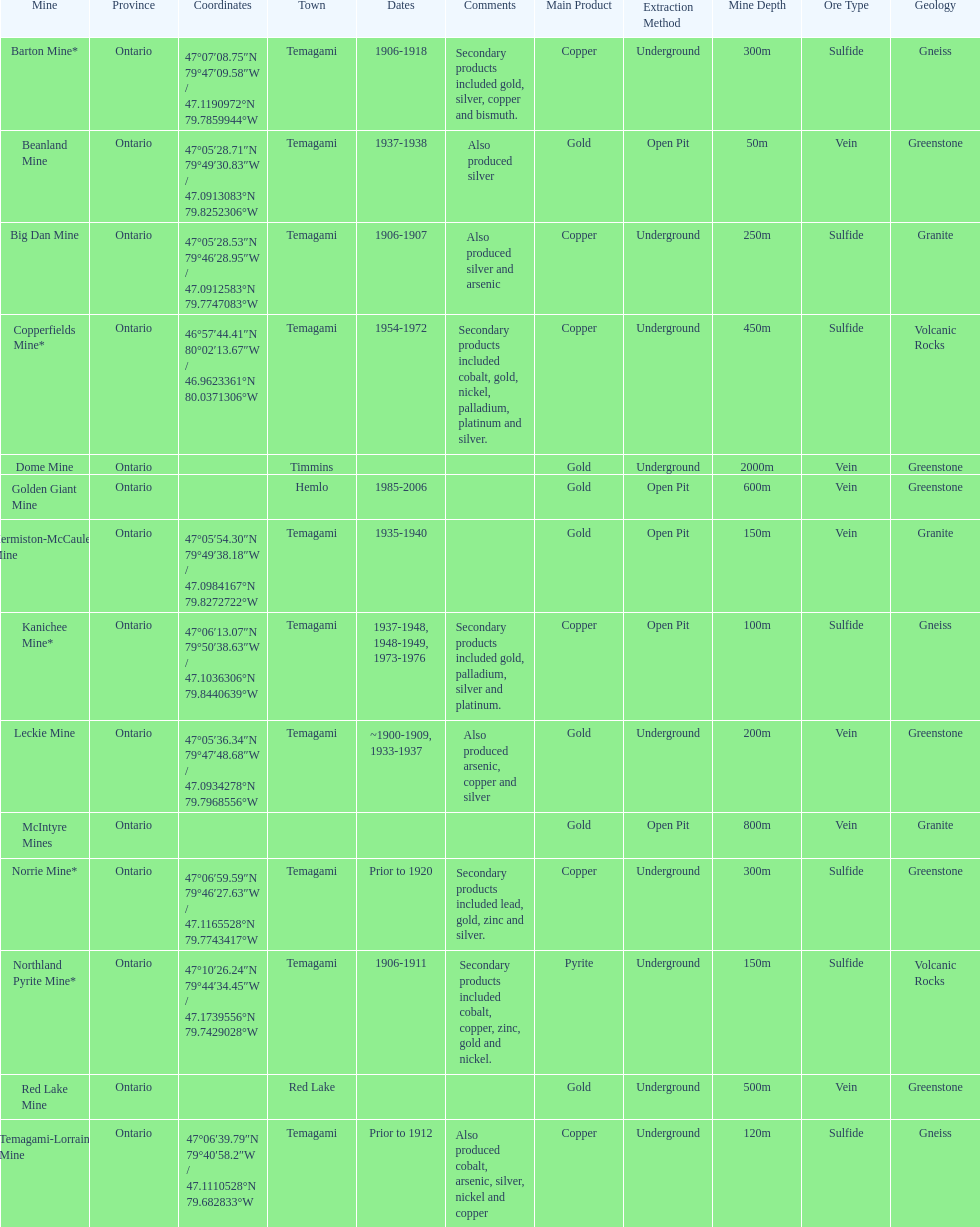Tell me the number of mines that also produced arsenic. 3. Help me parse the entirety of this table. {'header': ['Mine', 'Province', 'Coordinates', 'Town', 'Dates', 'Comments', 'Main Product', 'Extraction Method', 'Mine Depth', 'Ore Type', 'Geology'], 'rows': [['Barton Mine*', 'Ontario', '47°07′08.75″N 79°47′09.58″W\ufeff / \ufeff47.1190972°N 79.7859944°W', 'Temagami', '1906-1918', 'Secondary products included gold, silver, copper and bismuth.', 'Copper', 'Underground', '300m', 'Sulfide', 'Gneiss'], ['Beanland Mine', 'Ontario', '47°05′28.71″N 79°49′30.83″W\ufeff / \ufeff47.0913083°N 79.8252306°W', 'Temagami', '1937-1938', 'Also produced silver', 'Gold', 'Open Pit', '50m', 'Vein', 'Greenstone'], ['Big Dan Mine', 'Ontario', '47°05′28.53″N 79°46′28.95″W\ufeff / \ufeff47.0912583°N 79.7747083°W', 'Temagami', '1906-1907', 'Also produced silver and arsenic', 'Copper', 'Underground', '250m', 'Sulfide', 'Granite'], ['Copperfields Mine*', 'Ontario', '46°57′44.41″N 80°02′13.67″W\ufeff / \ufeff46.9623361°N 80.0371306°W', 'Temagami', '1954-1972', 'Secondary products included cobalt, gold, nickel, palladium, platinum and silver.', 'Copper', 'Underground', '450m', 'Sulfide', 'Volcanic Rocks'], ['Dome Mine', 'Ontario', '', 'Timmins', '', '', 'Gold', 'Underground', '2000m', 'Vein', 'Greenstone'], ['Golden Giant Mine', 'Ontario', '', 'Hemlo', '1985-2006', '', 'Gold', 'Open Pit', '600m', 'Vein', 'Greenstone'], ['Hermiston-McCauley Mine', 'Ontario', '47°05′54.30″N 79°49′38.18″W\ufeff / \ufeff47.0984167°N 79.8272722°W', 'Temagami', '1935-1940', '', 'Gold', 'Open Pit', '150m', 'Vein', 'Granite'], ['Kanichee Mine*', 'Ontario', '47°06′13.07″N 79°50′38.63″W\ufeff / \ufeff47.1036306°N 79.8440639°W', 'Temagami', '1937-1948, 1948-1949, 1973-1976', 'Secondary products included gold, palladium, silver and platinum.', 'Copper', 'Open Pit', '100m', 'Sulfide', 'Gneiss'], ['Leckie Mine', 'Ontario', '47°05′36.34″N 79°47′48.68″W\ufeff / \ufeff47.0934278°N 79.7968556°W', 'Temagami', '~1900-1909, 1933-1937', 'Also produced arsenic, copper and silver', 'Gold', 'Underground', '200m', 'Vein', 'Greenstone'], ['McIntyre Mines', 'Ontario', '', '', '', '', 'Gold', 'Open Pit', '800m', 'Vein', 'Granite'], ['Norrie Mine*', 'Ontario', '47°06′59.59″N 79°46′27.63″W\ufeff / \ufeff47.1165528°N 79.7743417°W', 'Temagami', 'Prior to 1920', 'Secondary products included lead, gold, zinc and silver.', 'Copper', 'Underground', '300m', 'Sulfide', 'Greenstone'], ['Northland Pyrite Mine*', 'Ontario', '47°10′26.24″N 79°44′34.45″W\ufeff / \ufeff47.1739556°N 79.7429028°W', 'Temagami', '1906-1911', 'Secondary products included cobalt, copper, zinc, gold and nickel.', 'Pyrite', 'Underground', '150m', 'Sulfide', 'Volcanic Rocks'], ['Red Lake Mine', 'Ontario', '', 'Red Lake', '', '', 'Gold', 'Underground', '500m', 'Vein', 'Greenstone'], ['Temagami-Lorrain Mine', 'Ontario', '47°06′39.79″N 79°40′58.2″W\ufeff / \ufeff47.1110528°N 79.682833°W', 'Temagami', 'Prior to 1912', 'Also produced cobalt, arsenic, silver, nickel and copper', 'Copper', 'Underground', '120m', 'Sulfide', 'Gneiss']]} 